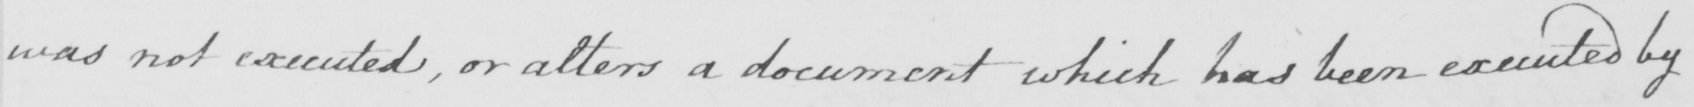Please transcribe the handwritten text in this image. was not executed , or alters a document which has been executed by 